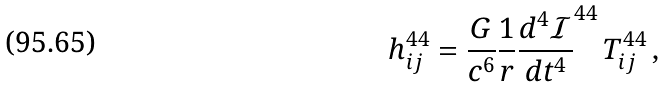Convert formula to latex. <formula><loc_0><loc_0><loc_500><loc_500>h _ { i j } ^ { 4 4 } = \frac { G } { c ^ { 6 } } \frac { 1 } { r } \frac { d ^ { 4 } \mathcal { I } } { d t ^ { 4 } } ^ { 4 4 } \, T _ { i j } ^ { 4 4 } \, ,</formula> 